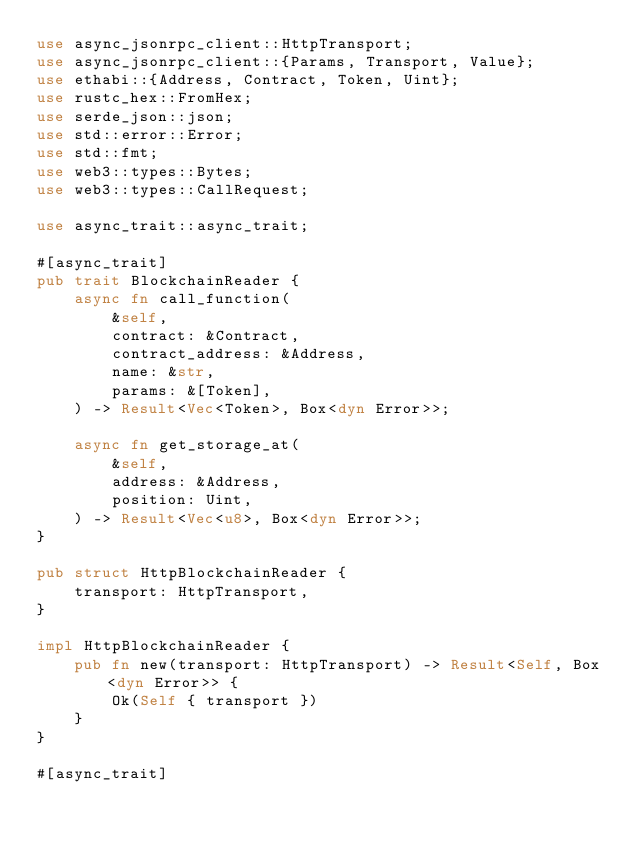Convert code to text. <code><loc_0><loc_0><loc_500><loc_500><_Rust_>use async_jsonrpc_client::HttpTransport;
use async_jsonrpc_client::{Params, Transport, Value};
use ethabi::{Address, Contract, Token, Uint};
use rustc_hex::FromHex;
use serde_json::json;
use std::error::Error;
use std::fmt;
use web3::types::Bytes;
use web3::types::CallRequest;

use async_trait::async_trait;

#[async_trait]
pub trait BlockchainReader {
    async fn call_function(
        &self,
        contract: &Contract,
        contract_address: &Address,
        name: &str,
        params: &[Token],
    ) -> Result<Vec<Token>, Box<dyn Error>>;

    async fn get_storage_at(
        &self,
        address: &Address,
        position: Uint,
    ) -> Result<Vec<u8>, Box<dyn Error>>;
}

pub struct HttpBlockchainReader {
    transport: HttpTransport,
}

impl HttpBlockchainReader {
    pub fn new(transport: HttpTransport) -> Result<Self, Box<dyn Error>> {
        Ok(Self { transport })
    }
}

#[async_trait]</code> 